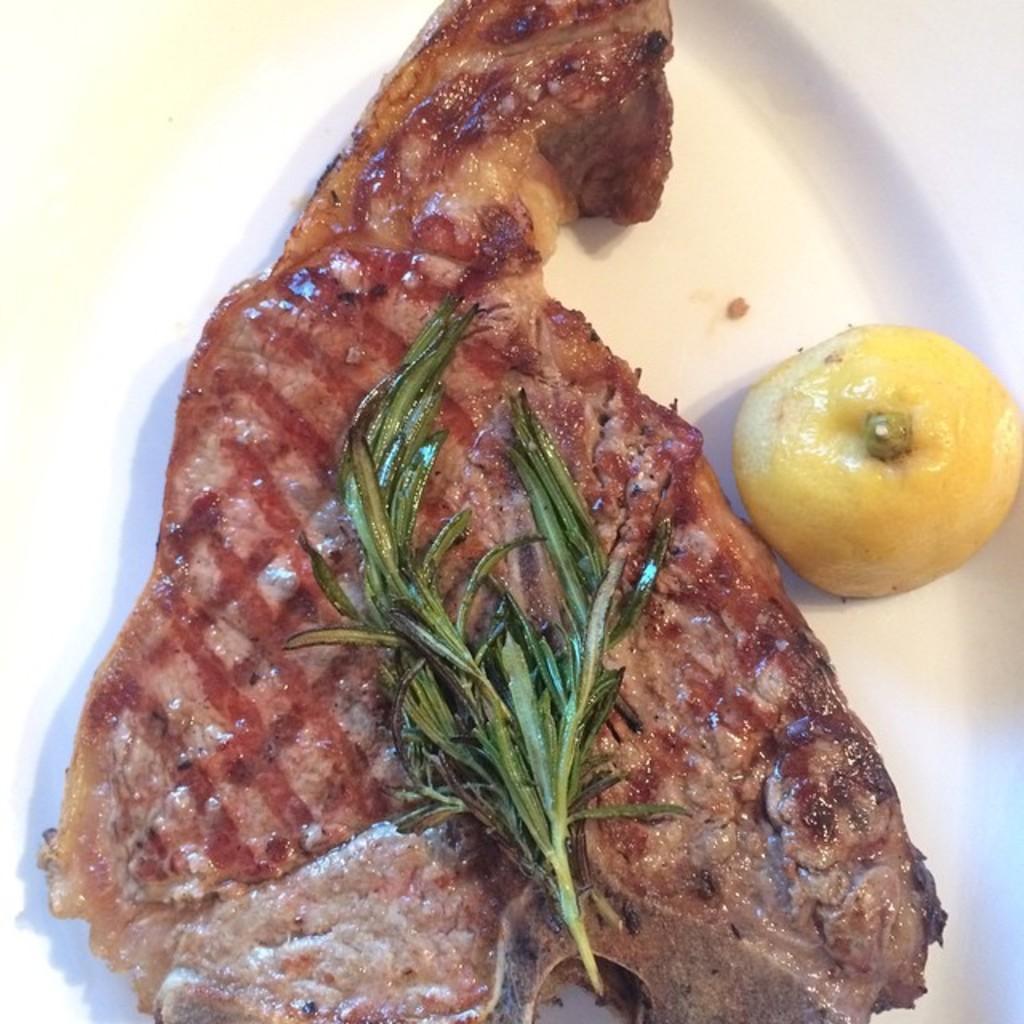Describe this image in one or two sentences. There is a white surface. On that there is a piece of meat with leaves and a lemon. 